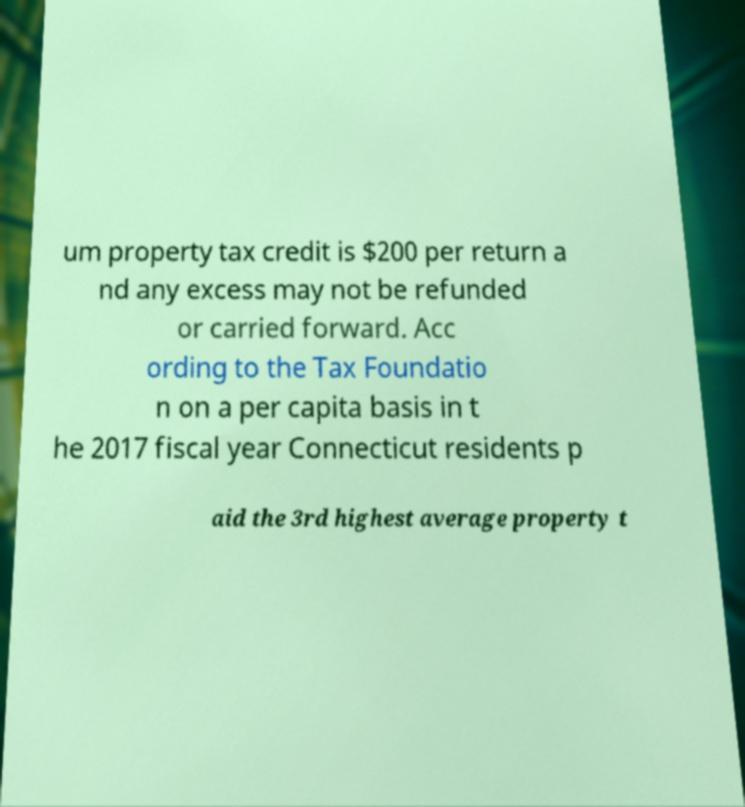What messages or text are displayed in this image? I need them in a readable, typed format. um property tax credit is $200 per return a nd any excess may not be refunded or carried forward. Acc ording to the Tax Foundatio n on a per capita basis in t he 2017 fiscal year Connecticut residents p aid the 3rd highest average property t 